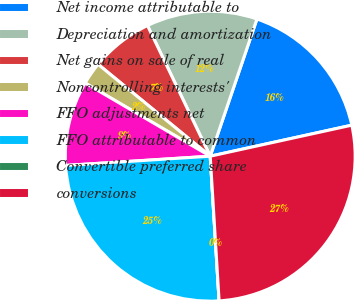Convert chart. <chart><loc_0><loc_0><loc_500><loc_500><pie_chart><fcel>Net income attributable to<fcel>Depreciation and amortization<fcel>Net gains on sale of real<fcel>Noncontrolling interests'<fcel>FFO adjustments net<fcel>FFO attributable to common<fcel>Convertible preferred share<fcel>conversions<nl><fcel>16.34%<fcel>12.35%<fcel>6.95%<fcel>2.5%<fcel>9.44%<fcel>24.96%<fcel>0.0%<fcel>27.46%<nl></chart> 